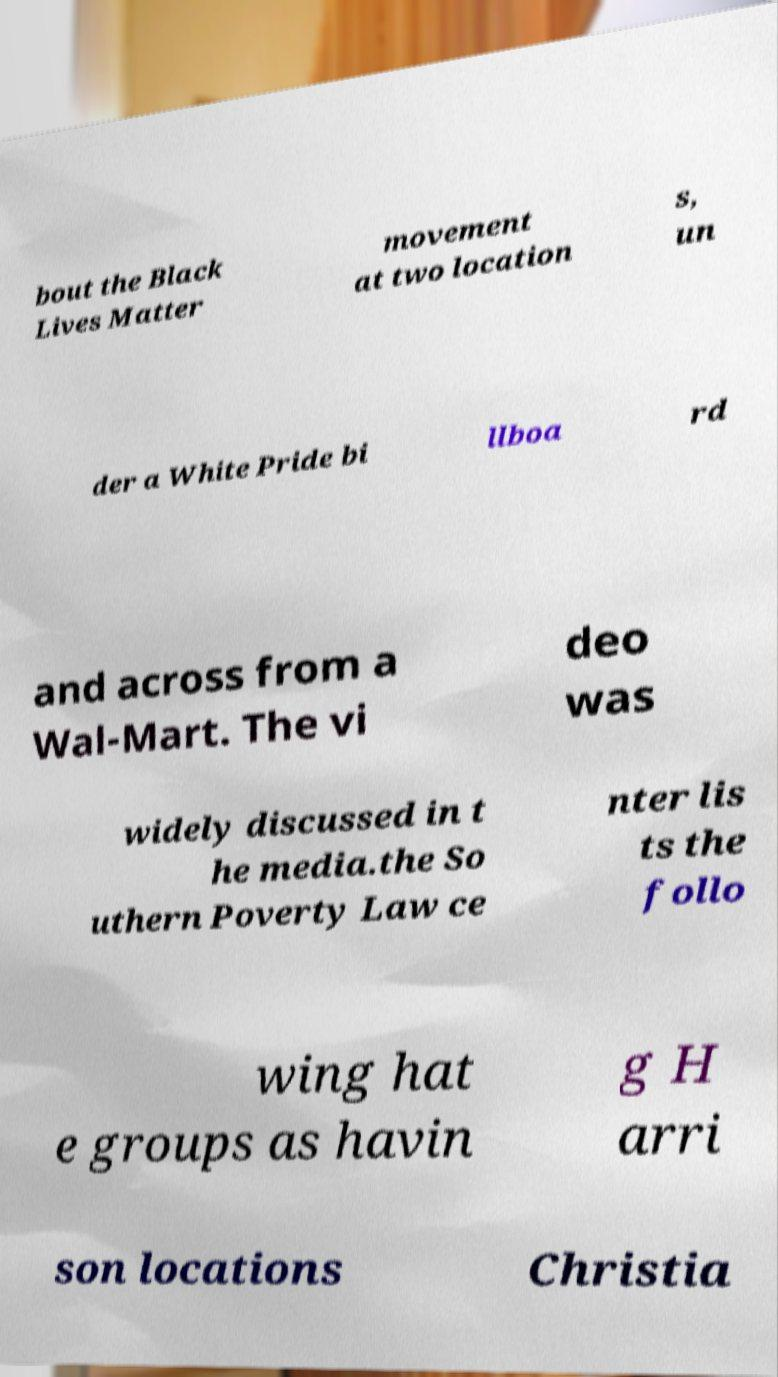Can you read and provide the text displayed in the image?This photo seems to have some interesting text. Can you extract and type it out for me? bout the Black Lives Matter movement at two location s, un der a White Pride bi llboa rd and across from a Wal-Mart. The vi deo was widely discussed in t he media.the So uthern Poverty Law ce nter lis ts the follo wing hat e groups as havin g H arri son locations Christia 